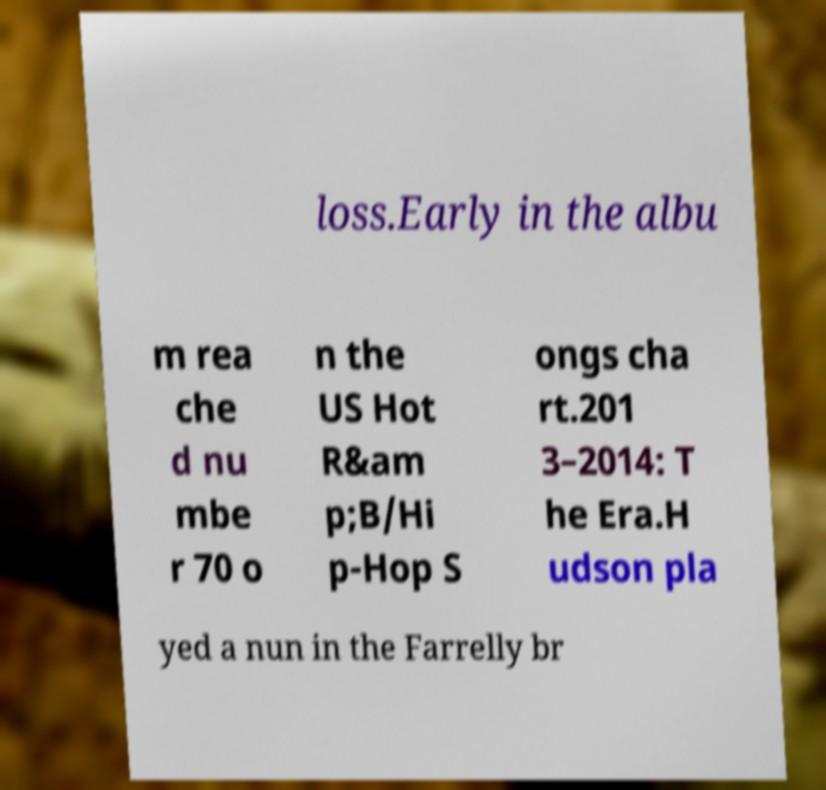What messages or text are displayed in this image? I need them in a readable, typed format. loss.Early in the albu m rea che d nu mbe r 70 o n the US Hot R&am p;B/Hi p-Hop S ongs cha rt.201 3–2014: T he Era.H udson pla yed a nun in the Farrelly br 